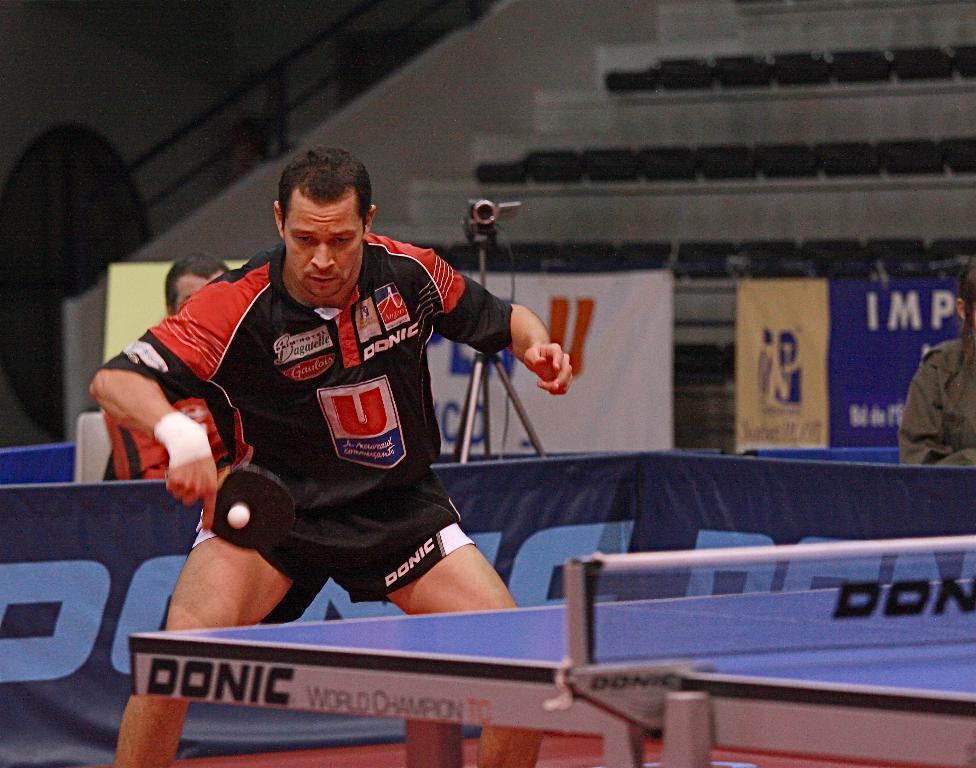Please provide a concise description of this image. In this image there is a man standing and playing table tennis near the table tennis board and at the back ground there is a camera attached to the tripod stand , and a man sitting in the chair , another person sitting in the chair and some chairs at the back side. 